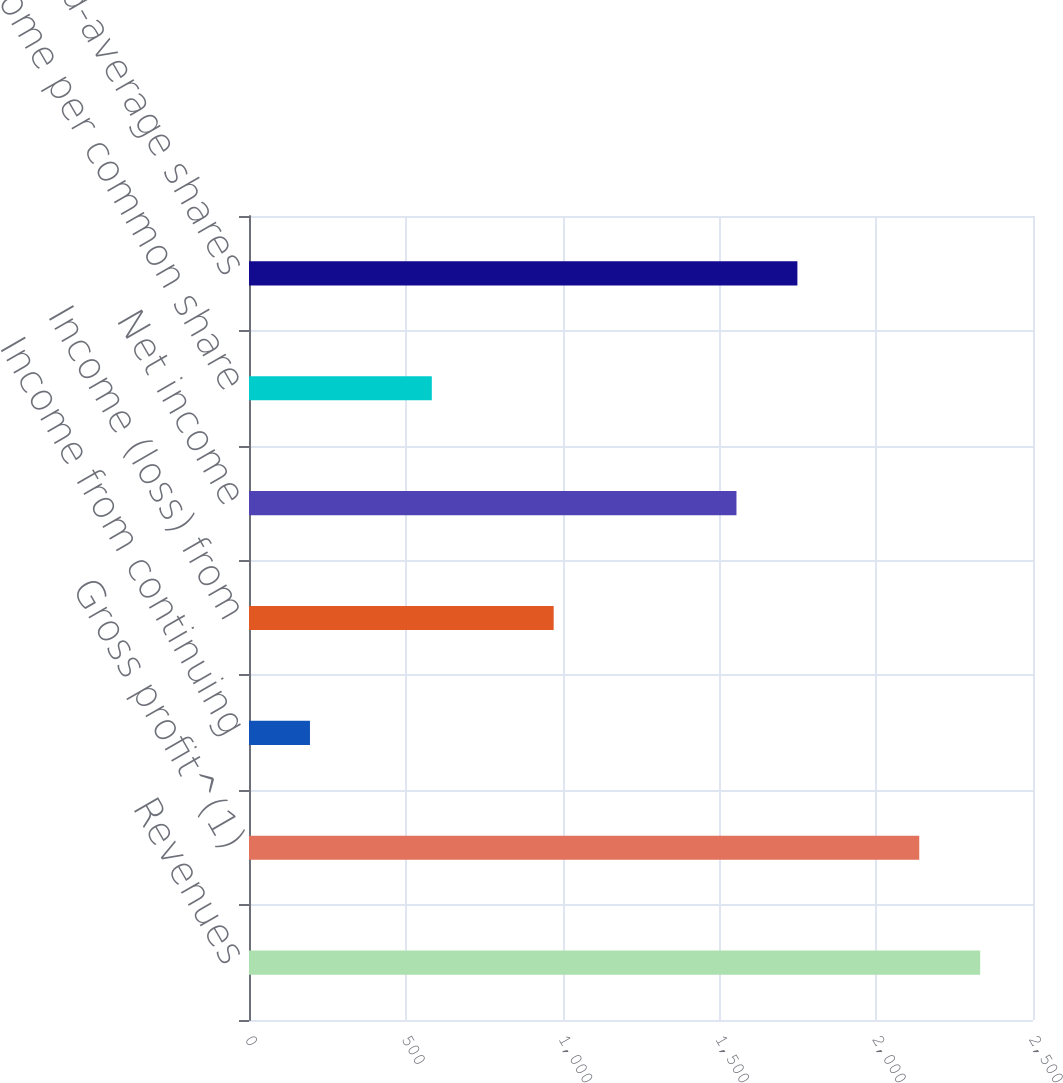Convert chart to OTSL. <chart><loc_0><loc_0><loc_500><loc_500><bar_chart><fcel>Revenues<fcel>Gross profit^(1)<fcel>Income from continuing<fcel>Income (loss) from<fcel>Net income<fcel>Net income per common share<fcel>Basic weighted-average shares<nl><fcel>2331.58<fcel>2137.29<fcel>194.39<fcel>971.55<fcel>1554.42<fcel>582.97<fcel>1748.71<nl></chart> 